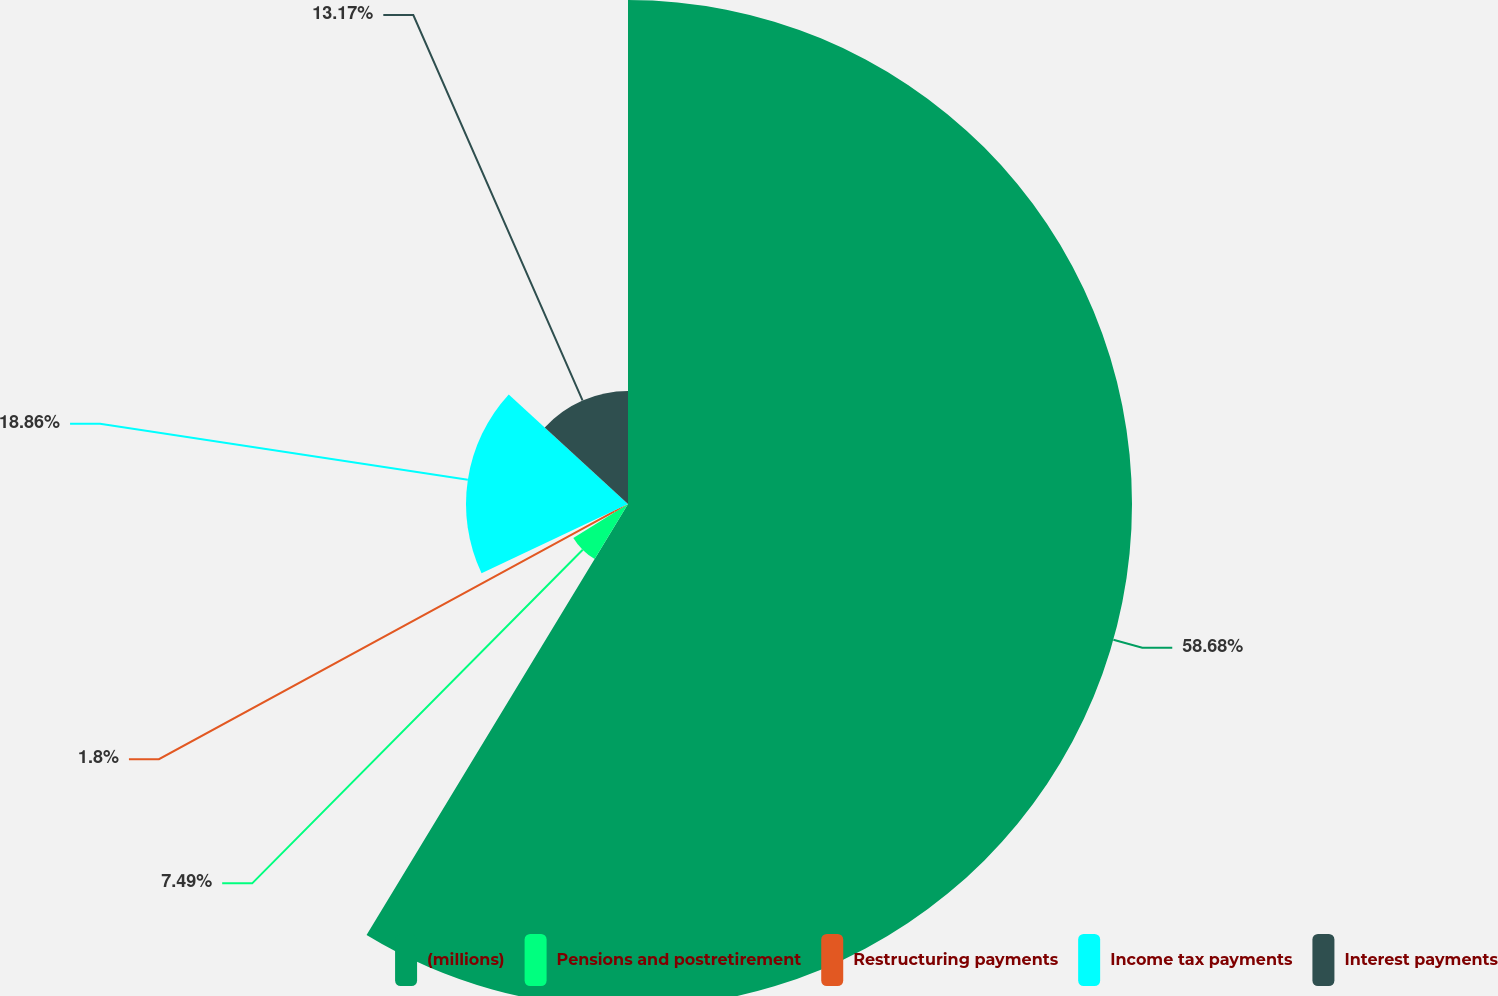Convert chart. <chart><loc_0><loc_0><loc_500><loc_500><pie_chart><fcel>(millions)<fcel>Pensions and postretirement<fcel>Restructuring payments<fcel>Income tax payments<fcel>Interest payments<nl><fcel>58.68%<fcel>7.49%<fcel>1.8%<fcel>18.86%<fcel>13.17%<nl></chart> 